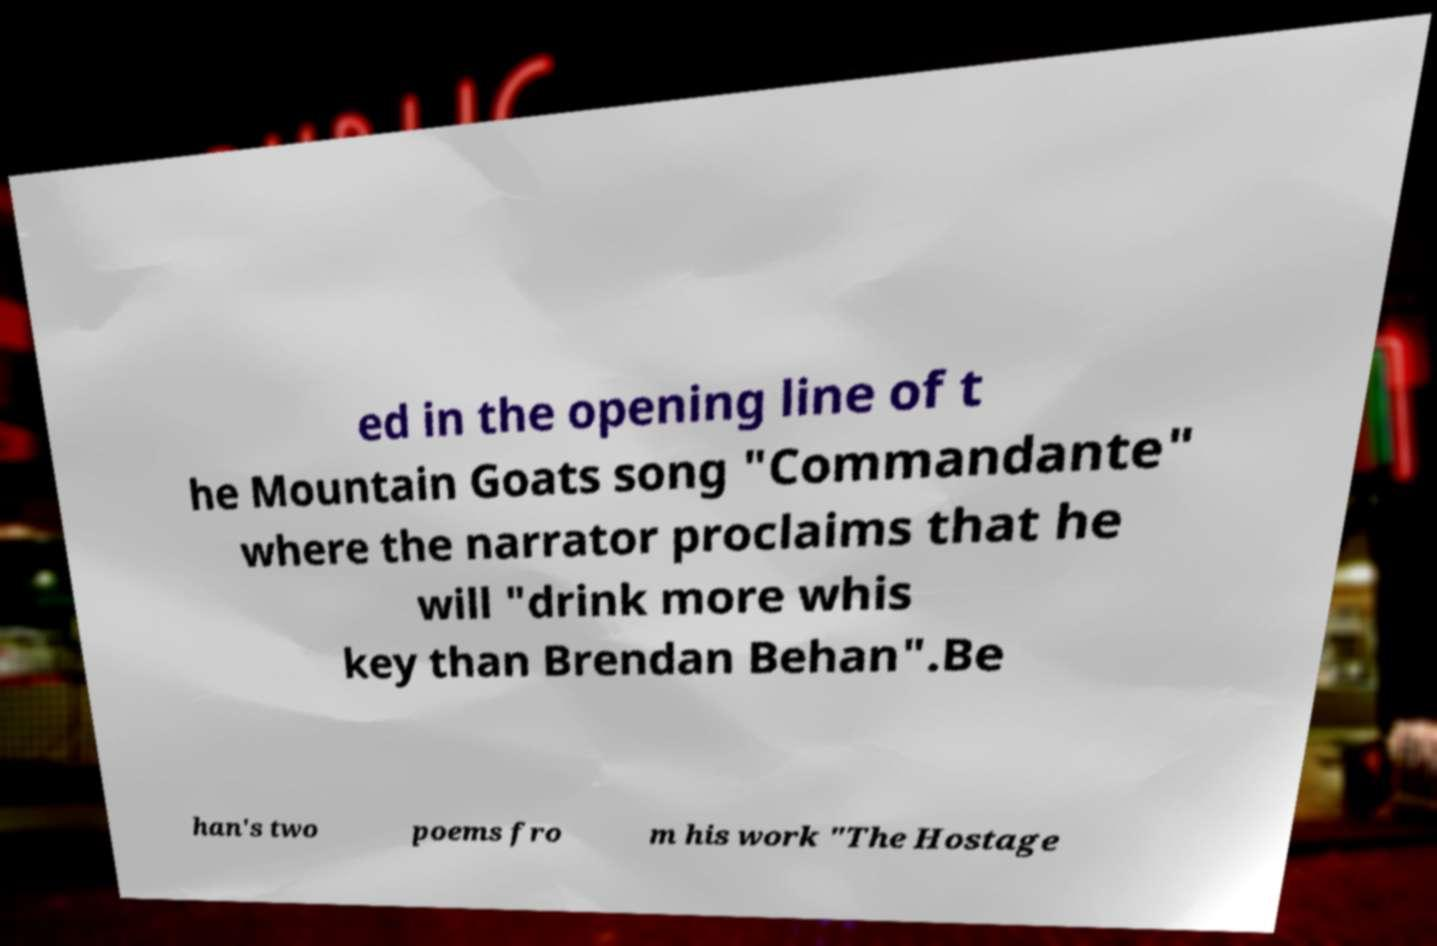For documentation purposes, I need the text within this image transcribed. Could you provide that? ed in the opening line of t he Mountain Goats song "Commandante" where the narrator proclaims that he will "drink more whis key than Brendan Behan".Be han's two poems fro m his work "The Hostage 